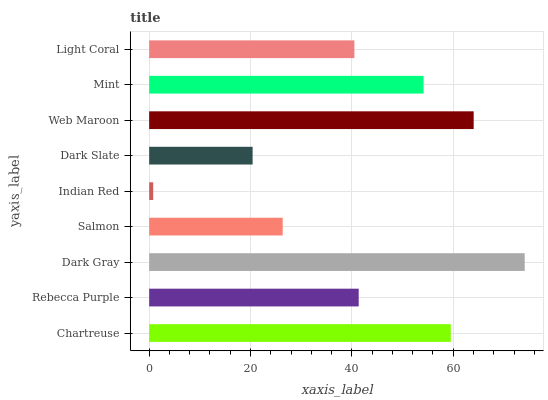Is Indian Red the minimum?
Answer yes or no. Yes. Is Dark Gray the maximum?
Answer yes or no. Yes. Is Rebecca Purple the minimum?
Answer yes or no. No. Is Rebecca Purple the maximum?
Answer yes or no. No. Is Chartreuse greater than Rebecca Purple?
Answer yes or no. Yes. Is Rebecca Purple less than Chartreuse?
Answer yes or no. Yes. Is Rebecca Purple greater than Chartreuse?
Answer yes or no. No. Is Chartreuse less than Rebecca Purple?
Answer yes or no. No. Is Rebecca Purple the high median?
Answer yes or no. Yes. Is Rebecca Purple the low median?
Answer yes or no. Yes. Is Light Coral the high median?
Answer yes or no. No. Is Dark Slate the low median?
Answer yes or no. No. 